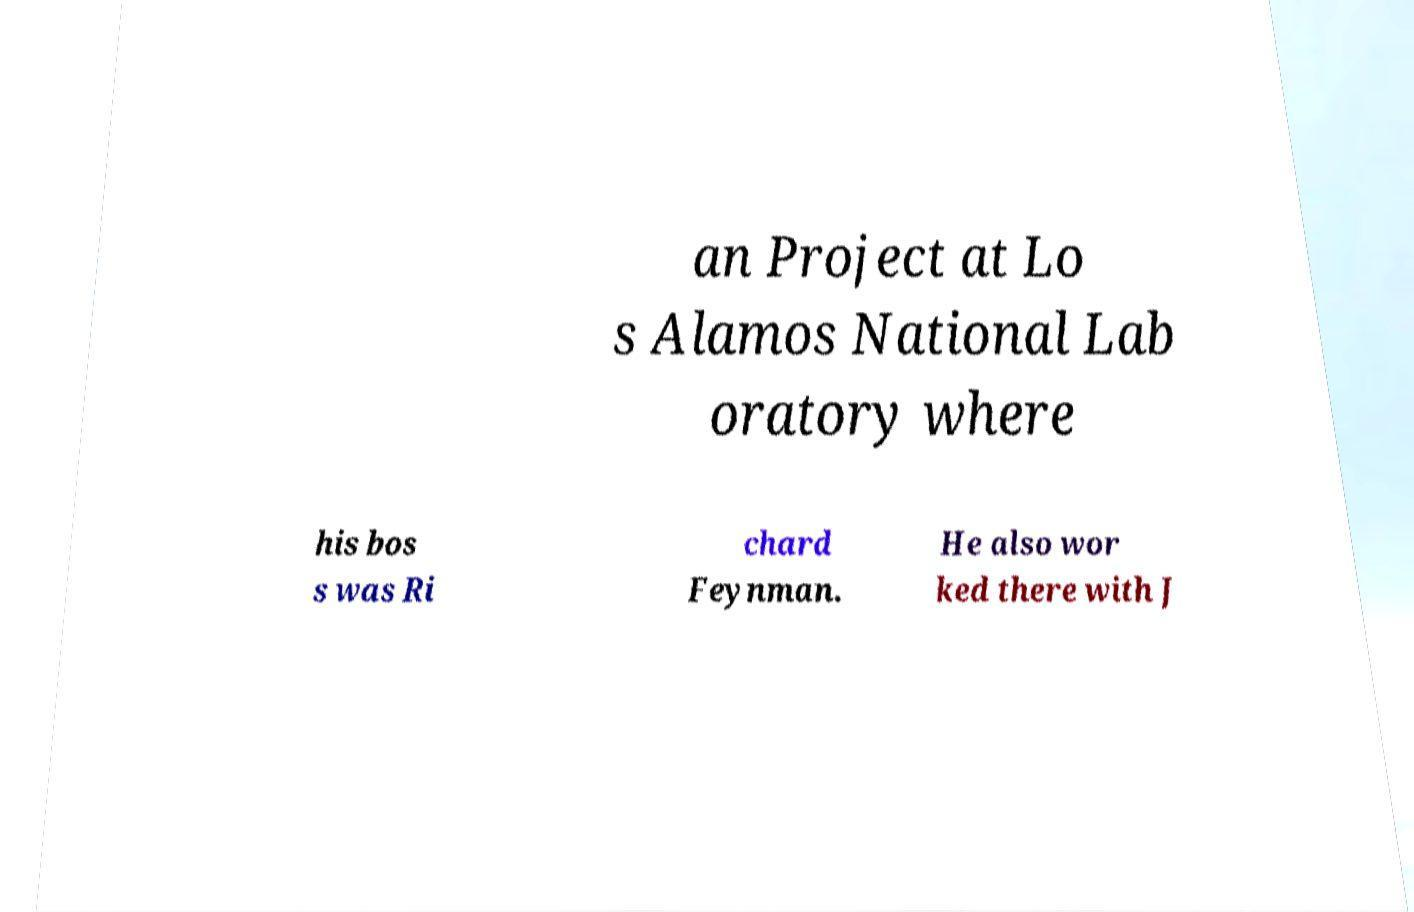Can you read and provide the text displayed in the image?This photo seems to have some interesting text. Can you extract and type it out for me? an Project at Lo s Alamos National Lab oratory where his bos s was Ri chard Feynman. He also wor ked there with J 